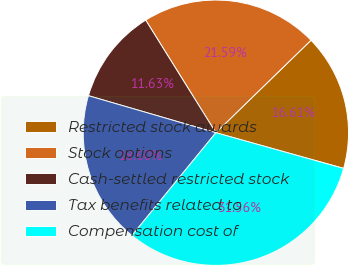<chart> <loc_0><loc_0><loc_500><loc_500><pie_chart><fcel>Restricted stock awards<fcel>Stock options<fcel>Cash-settled restricted stock<fcel>Tax benefits related to<fcel>Compensation cost of<nl><fcel>16.61%<fcel>21.59%<fcel>11.63%<fcel>18.6%<fcel>31.56%<nl></chart> 